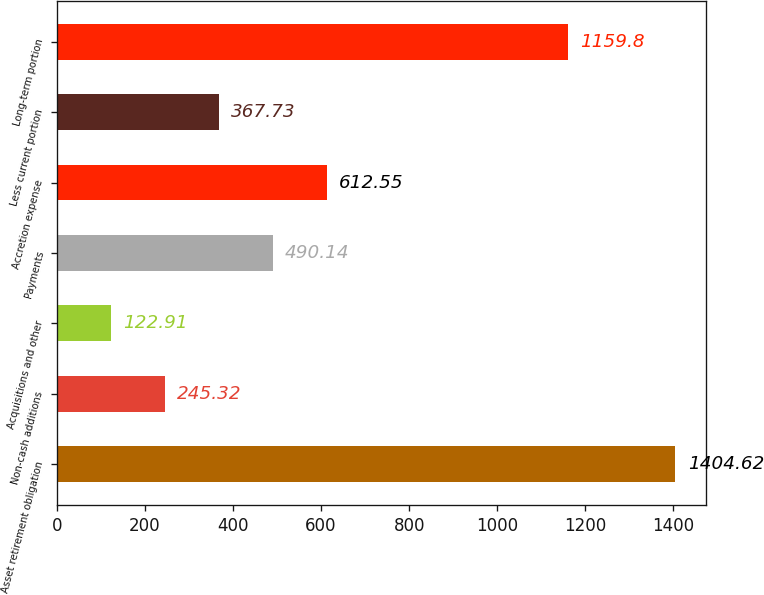<chart> <loc_0><loc_0><loc_500><loc_500><bar_chart><fcel>Asset retirement obligation<fcel>Non-cash additions<fcel>Acquisitions and other<fcel>Payments<fcel>Accretion expense<fcel>Less current portion<fcel>Long-term portion<nl><fcel>1404.62<fcel>245.32<fcel>122.91<fcel>490.14<fcel>612.55<fcel>367.73<fcel>1159.8<nl></chart> 